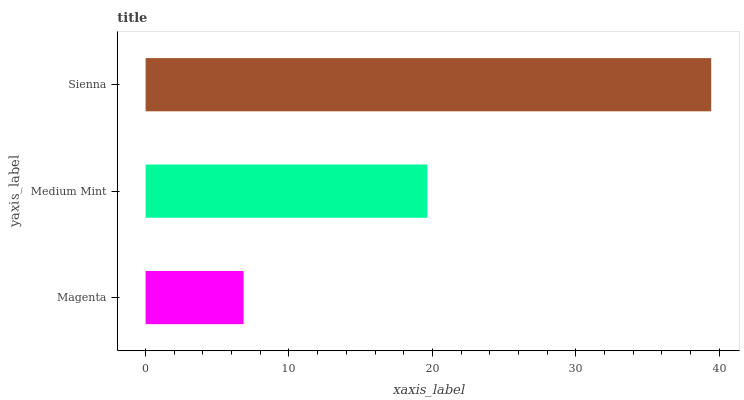Is Magenta the minimum?
Answer yes or no. Yes. Is Sienna the maximum?
Answer yes or no. Yes. Is Medium Mint the minimum?
Answer yes or no. No. Is Medium Mint the maximum?
Answer yes or no. No. Is Medium Mint greater than Magenta?
Answer yes or no. Yes. Is Magenta less than Medium Mint?
Answer yes or no. Yes. Is Magenta greater than Medium Mint?
Answer yes or no. No. Is Medium Mint less than Magenta?
Answer yes or no. No. Is Medium Mint the high median?
Answer yes or no. Yes. Is Medium Mint the low median?
Answer yes or no. Yes. Is Magenta the high median?
Answer yes or no. No. Is Sienna the low median?
Answer yes or no. No. 